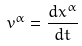Convert formula to latex. <formula><loc_0><loc_0><loc_500><loc_500>v ^ { \alpha } = \frac { d x ^ { \alpha } } { d t }</formula> 